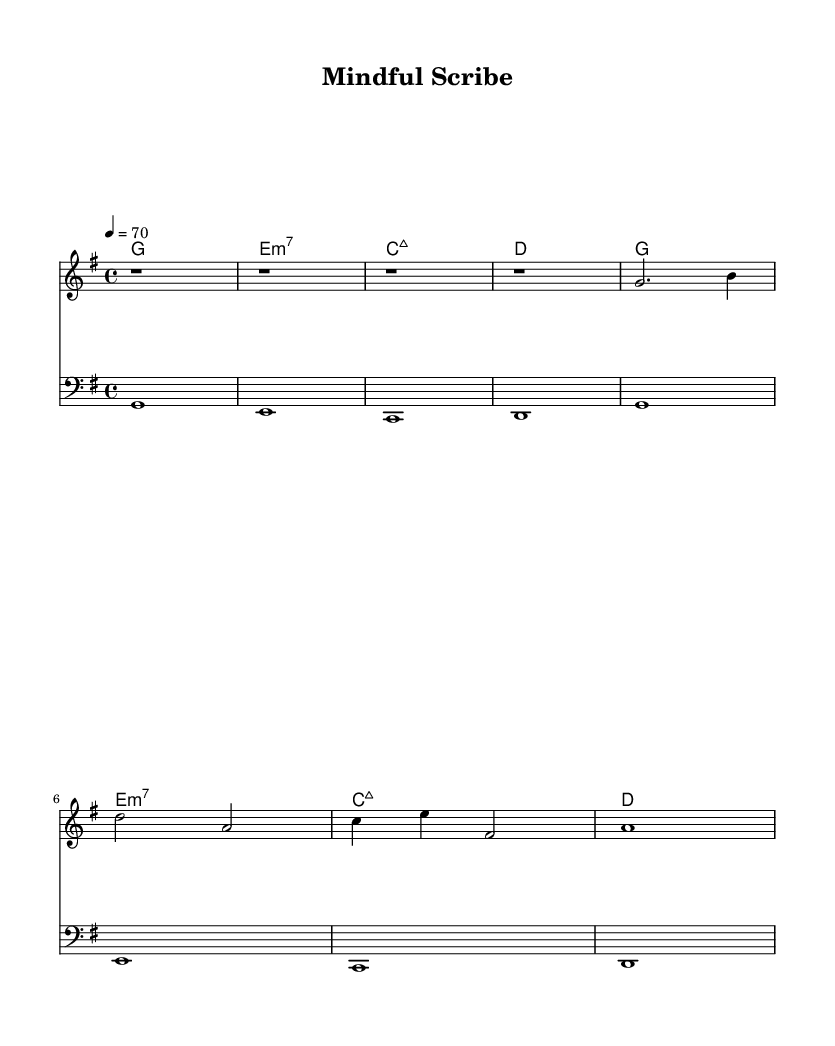What is the key signature of this music? The key signature indicated at the beginning of the score shows one sharp (F#), which corresponds to G major.
Answer: G major What is the time signature of this music? The time signature is located at the start of the sheet music, represented as a fraction, and is shown as 4/4, meaning there are four beats in each measure.
Answer: 4/4 What is the tempo of the piece? The tempo marking is specified with a metronome indication next to the tempo text. It shows 4 beats per minute, set to 70.
Answer: 70 How many measures are in the melody? To find the number of measures, we can count the segments divided by bar lines in the melody. There are a total of 8 measures present.
Answer: 8 What is the first chord presented in the harmony? The first chord in the chord section is indicated below the melody and is a G major chord, which is denoted as 'g1'.
Answer: G major What type of music is represented by the sheet? The use of ambient tones, slow tempo, and the overall structure indicates that this composition is classified as ambient electronic music, suitable for writing and concentration.
Answer: Ambient electronic What is the starting note of the melody? The first note of the melody is indicated at the beginning of the staff and is a rest, followed by the note G which is the first pitch played.
Answer: G 